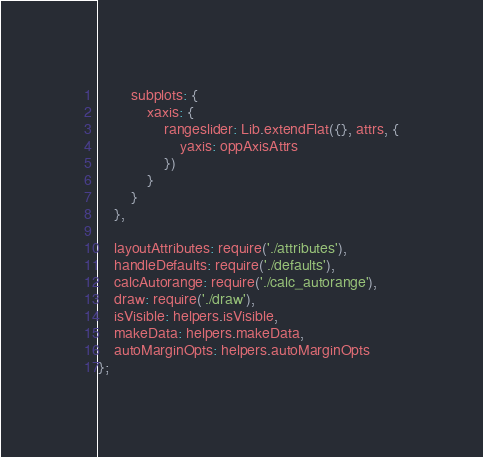<code> <loc_0><loc_0><loc_500><loc_500><_JavaScript_>        subplots: {
            xaxis: {
                rangeslider: Lib.extendFlat({}, attrs, {
                    yaxis: oppAxisAttrs
                })
            }
        }
    },

    layoutAttributes: require('./attributes'),
    handleDefaults: require('./defaults'),
    calcAutorange: require('./calc_autorange'),
    draw: require('./draw'),
    isVisible: helpers.isVisible,
    makeData: helpers.makeData,
    autoMarginOpts: helpers.autoMarginOpts
};
</code> 